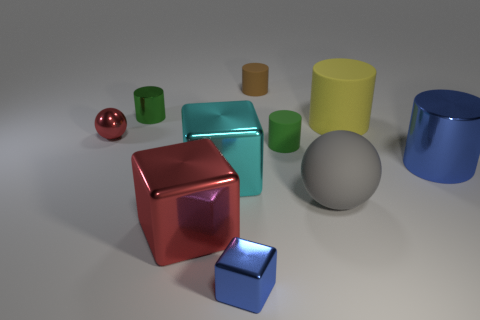Which objects seem to reflect the most light? The objects with the most reflective surfaces are the metallic spheres and cylinders; they exhibit highlights and mirrored reflections of the environment, indicating their glossy finish. Specifically, the red metallic sphere and the large blue metallic cylinder are among the most reflective in the scene. 